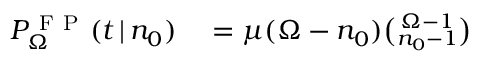<formula> <loc_0><loc_0><loc_500><loc_500>\begin{array} { r l } { P _ { \Omega } ^ { F P } ( t \, | \, n _ { 0 } ) } & = \mu ( \Omega - n _ { 0 } ) { \binom { \Omega - 1 } { n _ { 0 } - 1 } } } \end{array}</formula> 